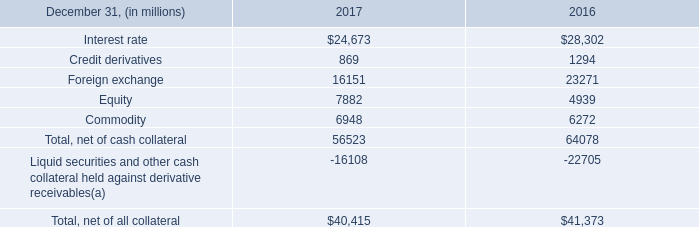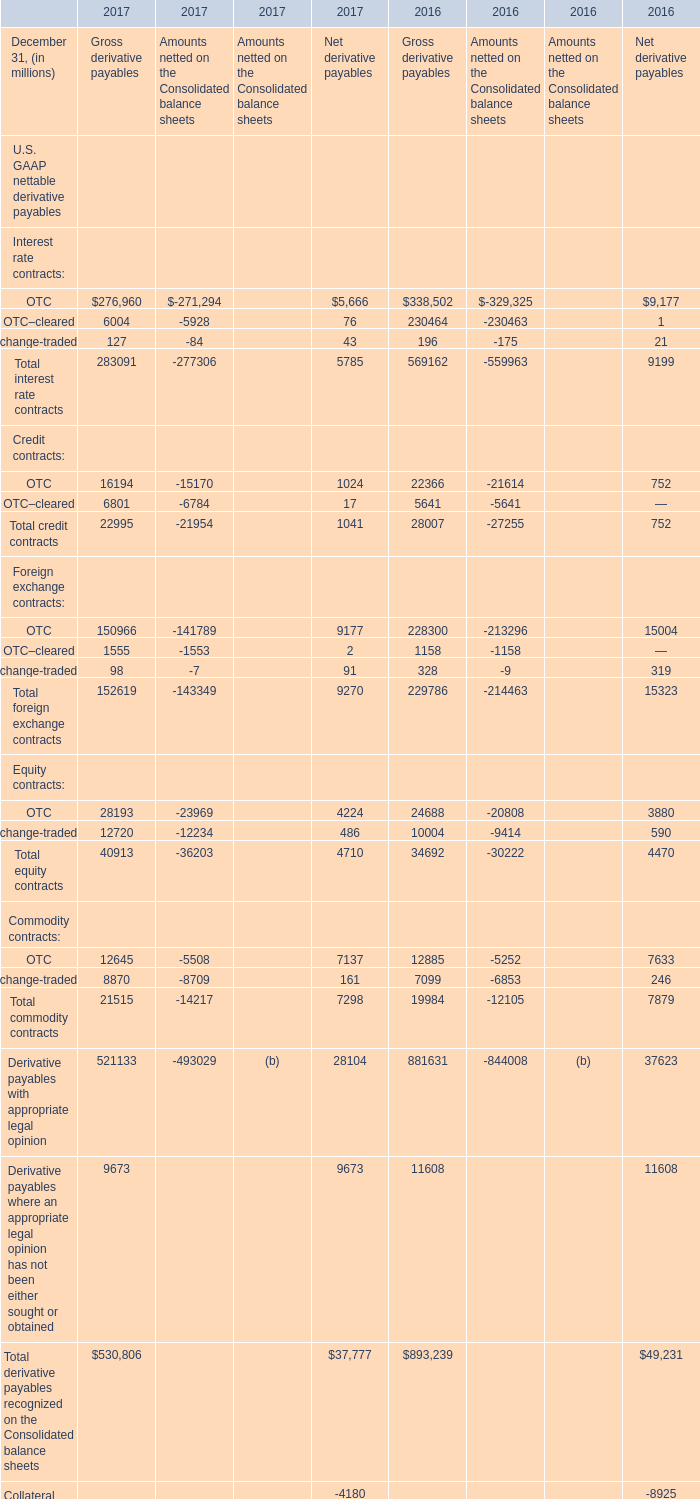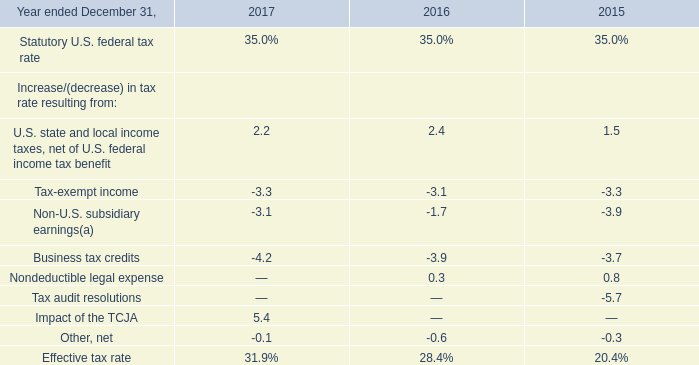what was the percent of avg exposure on the 2017 derivative receivables? 
Computations: (29.0 / 40.4)
Answer: 0.71782. 